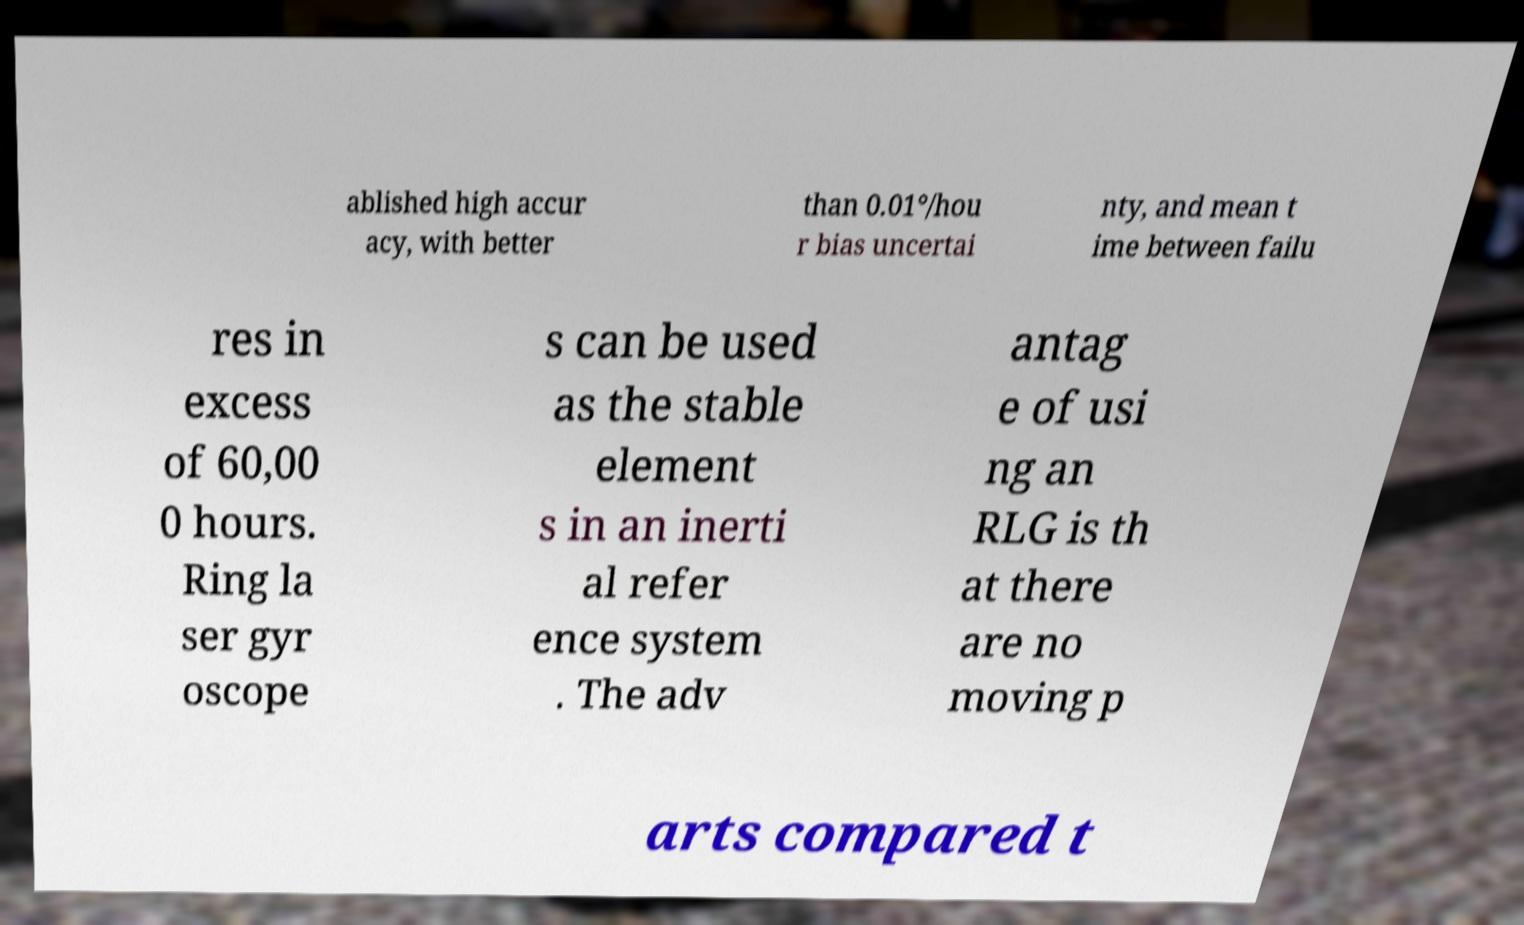Could you extract and type out the text from this image? ablished high accur acy, with better than 0.01°/hou r bias uncertai nty, and mean t ime between failu res in excess of 60,00 0 hours. Ring la ser gyr oscope s can be used as the stable element s in an inerti al refer ence system . The adv antag e of usi ng an RLG is th at there are no moving p arts compared t 